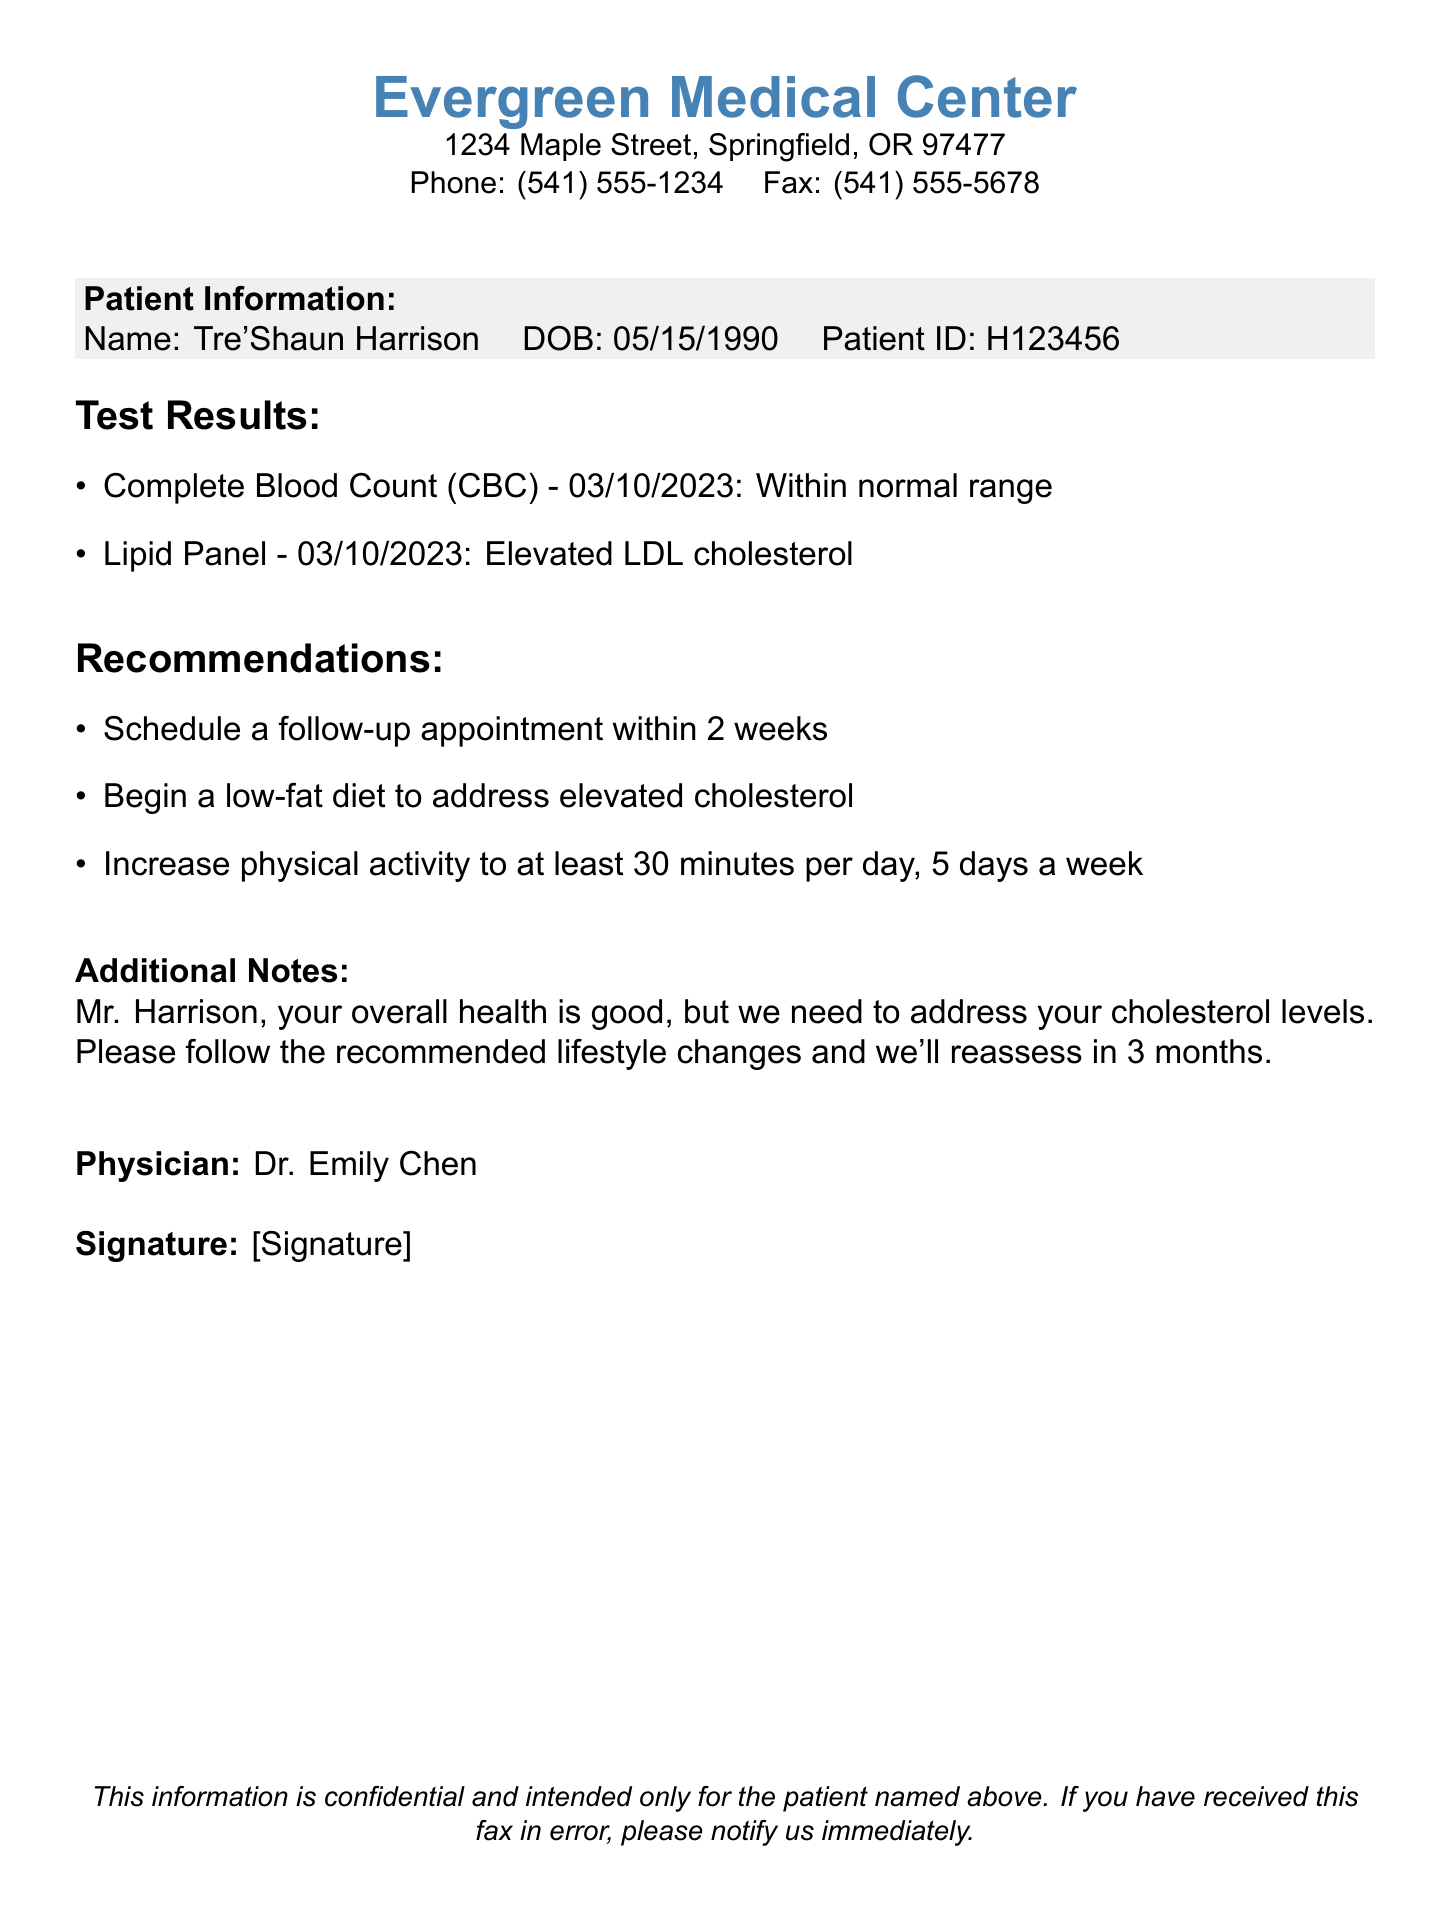What is the patient's name? The document specifies that the patient's name is Tre'Shaun Harrison.
Answer: Tre'Shaun Harrison What is the date of the lipid panel test? The lipid panel test is dated 03/10/2023 according to the test results section.
Answer: 03/10/2023 What is the normal range result for the Complete Blood Count? The document indicates that the Complete Blood Count (CBC) result is within normal range.
Answer: Within normal range What lifestyle change is recommended to address elevated cholesterol? The recommendations state to begin a low-fat diet to address the elevated cholesterol levels.
Answer: Low-fat diet Who is the physician listed in the document? The physician mentioned in the document is Dr. Emily Chen.
Answer: Dr. Emily Chen How long should Tre'Shaun wait for his follow-up appointment? The document recommends scheduling a follow-up appointment within 2 weeks.
Answer: 2 weeks What additional activity is suggested? The recommendations include increasing physical activity to at least 30 minutes per day.
Answer: 30 minutes per day In how many months will Tre'Shaun's cholesterol levels be reassessed? The document states that cholesterol levels will be reassessed in 3 months.
Answer: 3 months What is the phone number of the Evergreen Medical Center? The document provides the phone number as (541) 555-1234.
Answer: (541) 555-1234 